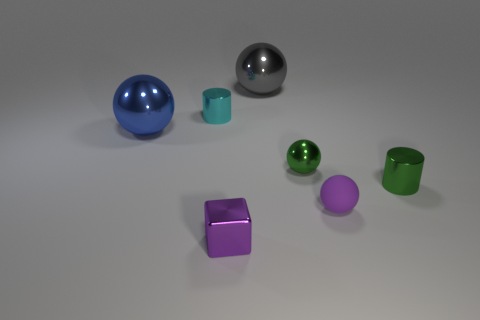Subtract all small purple balls. How many balls are left? 3 Add 1 blue balls. How many objects exist? 8 Subtract all blue balls. How many balls are left? 3 Add 5 spheres. How many spheres exist? 9 Subtract 1 purple blocks. How many objects are left? 6 Subtract all cylinders. How many objects are left? 5 Subtract all gray balls. Subtract all brown cubes. How many balls are left? 3 Subtract all tiny purple matte things. Subtract all small matte balls. How many objects are left? 5 Add 1 objects. How many objects are left? 8 